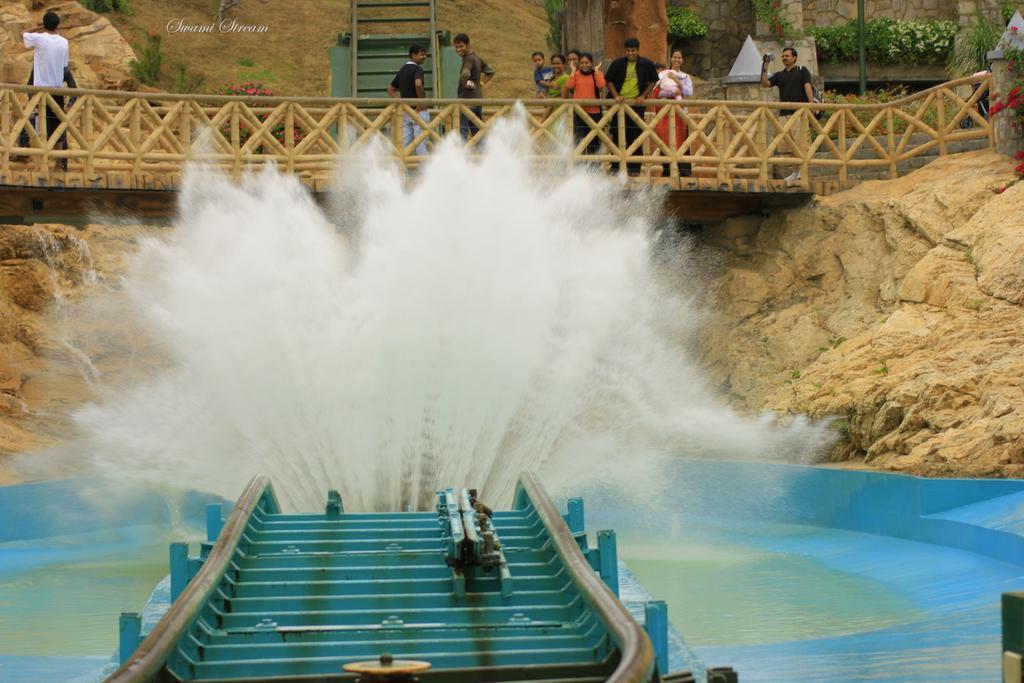Describe this image in one or two sentences. This picture is clicked outside. In the foreground we can see the slide and the water in the air and we can see the water body. In the background we can see the building, railings, group of people, camera, plants, flowers, rocks, stairs and some other items and we can see the watermark on the image. 